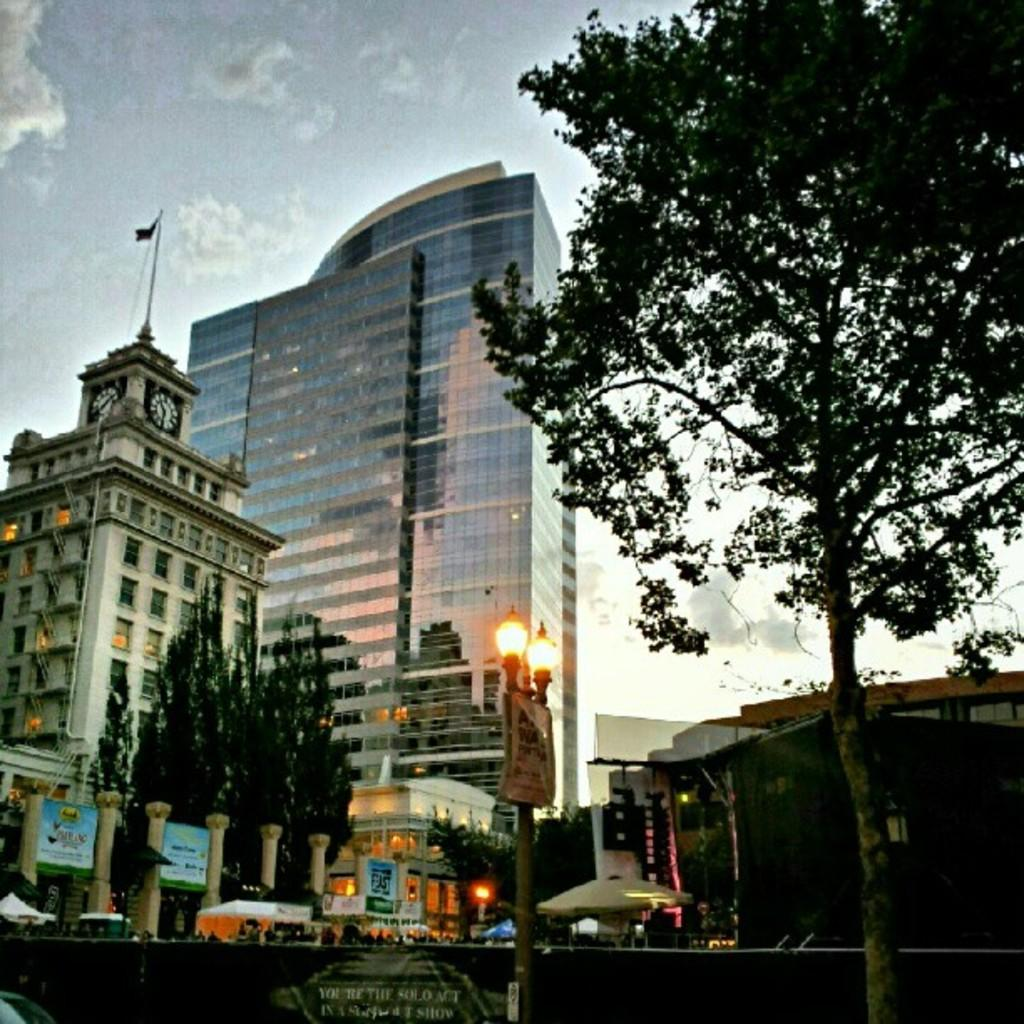What is the main object in the image? There is a pole in the image. What else can be seen in the image besides the pole? There are lights, trees, buildings, hoardings, tents, and clouds in the image. Can you describe the lights in the image? The lights are likely attached to the pole. What type of structures can be seen in the background? There are buildings, hoardings, and tents in the background. What is visible in the sky in the image? There are clouds in the sky in the image. What type of fowl can be seen swimming in the lake in the image? There is no lake or fowl present in the image. How much payment is required to enter the tents in the image? There is no indication of payment or entrance fees for the tents in the image. 